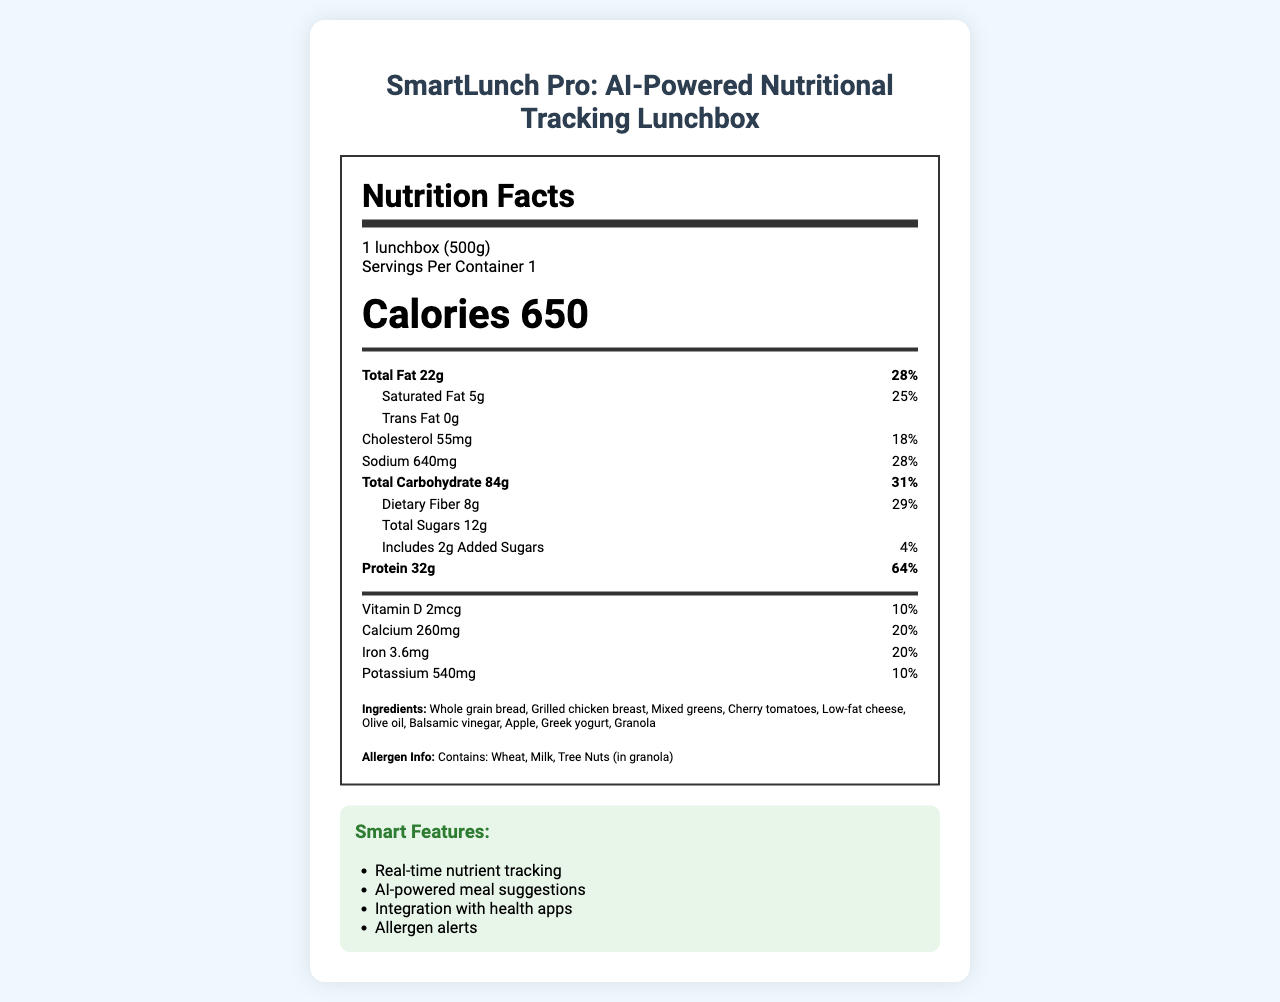when considering the serving size, how many servings are there in a container? The document mentions "Servings Per Container 1" in the serving information section.
Answer: 1 what is the total fat content in the lunchbox? The document states "Total Fat 22g" in the nutritional facts panel.
Answer: 22g how much Calcium does this lunchbox provide? The nutrition label lists "Calcium 260mg" and specifies its daily value as 20%.
Answer: 260mg which allergens are present in the ingredients? The allergen information section indicates that the lunchbox contains wheat, milk, and tree nuts (in granola).
Answer: Wheat, Milk, Tree Nuts what is the purpose of the AI-powered meal suggestions feature? The document lists "AI-powered meal suggestions" under the smart features, suggesting it helps users with personalized meal recommendations.
Answer: To provide personalized meal recommendations based on real-time nutrient tracking what is the total carbohydrate amount in one serving? The nutritional panel lists "Total Carbohydrate 84g" along with its daily value of 31%.
Answer: 84g what types of sensors are embedded in the SmartLunch Pro lunchbox? The document lists these sensors under the tech specs section.
Answer: Weight sensor, Temperature sensor, Optical food recognition sensor, Humidity sensor how much Vitamin D does this lunchbox provide? The nutrition facts section mentions "Vitamin D 2mcg" with a daily value of 10%.
Answer: 2mcg what is the major ingredient in the lunchbox? The document lists various ingredients, but it doesn't specify which ingredient is the major one.
Answer: Not enough information what serving size is considered for the nutrition facts in the document? Serving size specified is "1 lunchbox (500g)" in the serving info section.
Answer: 1 lunchbox (500g) what is the daily value percentage of protein provided? The nutrition section indicates "Protein 32g" with a daily value of 64%.
Answer: 64% does the lunchbox contain any trans fat? The nutrition facts list "Trans Fat 0g," indicating no trans fat is present.
Answer: No which vitamin or mineral has the highest daily value percentage? 
i. Vitamin D
ii. Calcium
iii. Iron
iv. Protein The nutritional facts panel indicates "Protein 64%" daily value, which is the highest among the listed nutrients.
Answer: iv. Protein which smart feature does this product have?
a. Voice activation
b. AI-powered meal suggestions
c. Heart rate monitoring The document mentions "AI-powered meal suggestions" under smart features.
Answer: b. AI-powered meal suggestions can you describe the main features of the SmartLunch Pro lunchbox? This summary combines both the product's tech specifications and its educational and functional features as presented in the document.
Answer: The SmartLunch Pro lunchbox is an AI-powered device for nutritional tracking. It features real-time nutrient monitoring, AI meal suggestions, and integration with health apps. It helps with portion control, nutritional awareness, and encourages healthy eating habits. The lunchbox is equipped with various sensors such as weight, temperature, optical food recognition, and humidity. It has a battery life of up to 7 days and is compatible with iOS and Android devices. is the SmartLunch Pro compatible with Android 9.0+? The document specifies that the SmartLunch Pro is compatible with iOS 14.0+ and Android 10.0+. Android 9.0+ compatibility is not mentioned.
Answer: No 